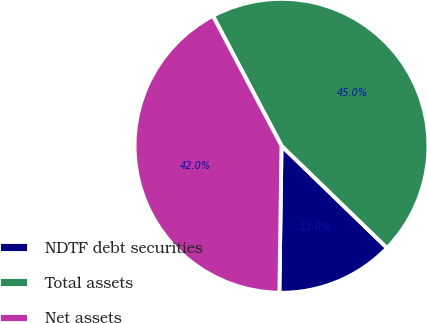Convert chart to OTSL. <chart><loc_0><loc_0><loc_500><loc_500><pie_chart><fcel>NDTF debt securities<fcel>Total assets<fcel>Net assets<nl><fcel>12.99%<fcel>44.97%<fcel>42.04%<nl></chart> 